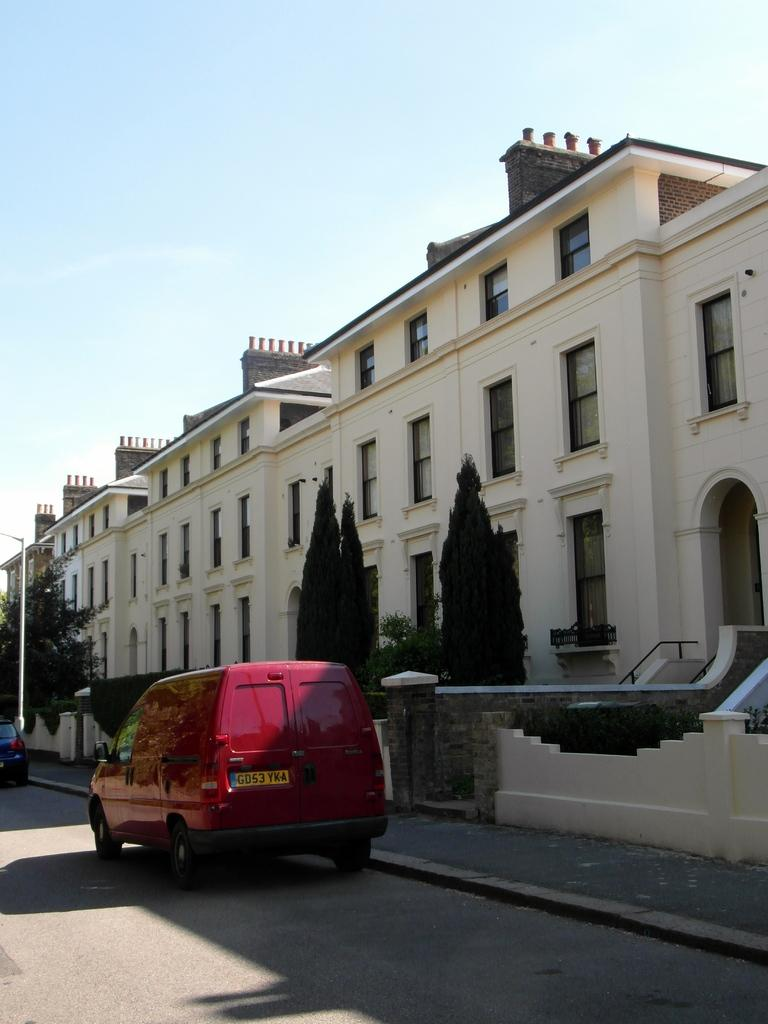What type of structure is present in the image? There is a building in the image. What natural elements can be seen in the image? There are trees in the image. What is the tall, vertical object in the image? There is a pole in the image. What type of barrier surrounds the area in the image? There is a compound wall in the image. What part of the natural environment is visible in the image? The sky is visible in the image. What type of transportation is present in the image? There are vehicles in the image. Where are the vehicles located in the image? The vehicles are on a road in the image. How many men can be seen in the image? There is no mention of men in the image, so it is not possible to determine how many are present. What sense is being stimulated by the things in the image? The provided facts do not mention any specific sensory experiences, so it is not possible to determine which sense is being stimulated. 